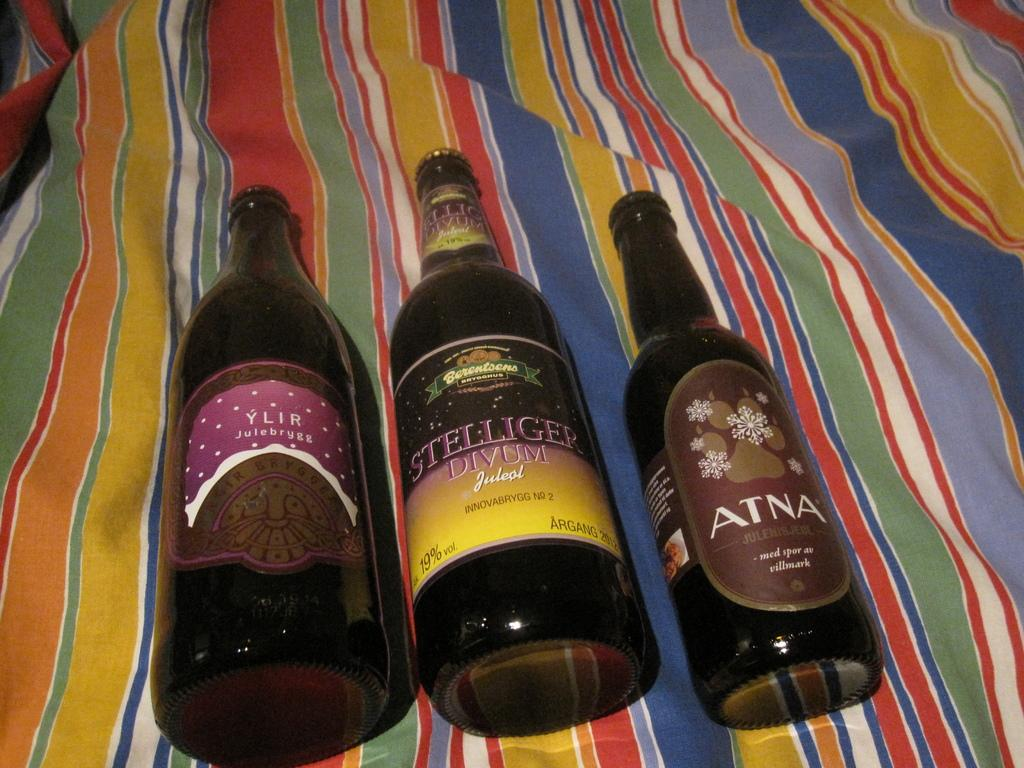<image>
Relay a brief, clear account of the picture shown. Bottles of YLIR, Stelliger Divum and Atna on a striped sheet. 